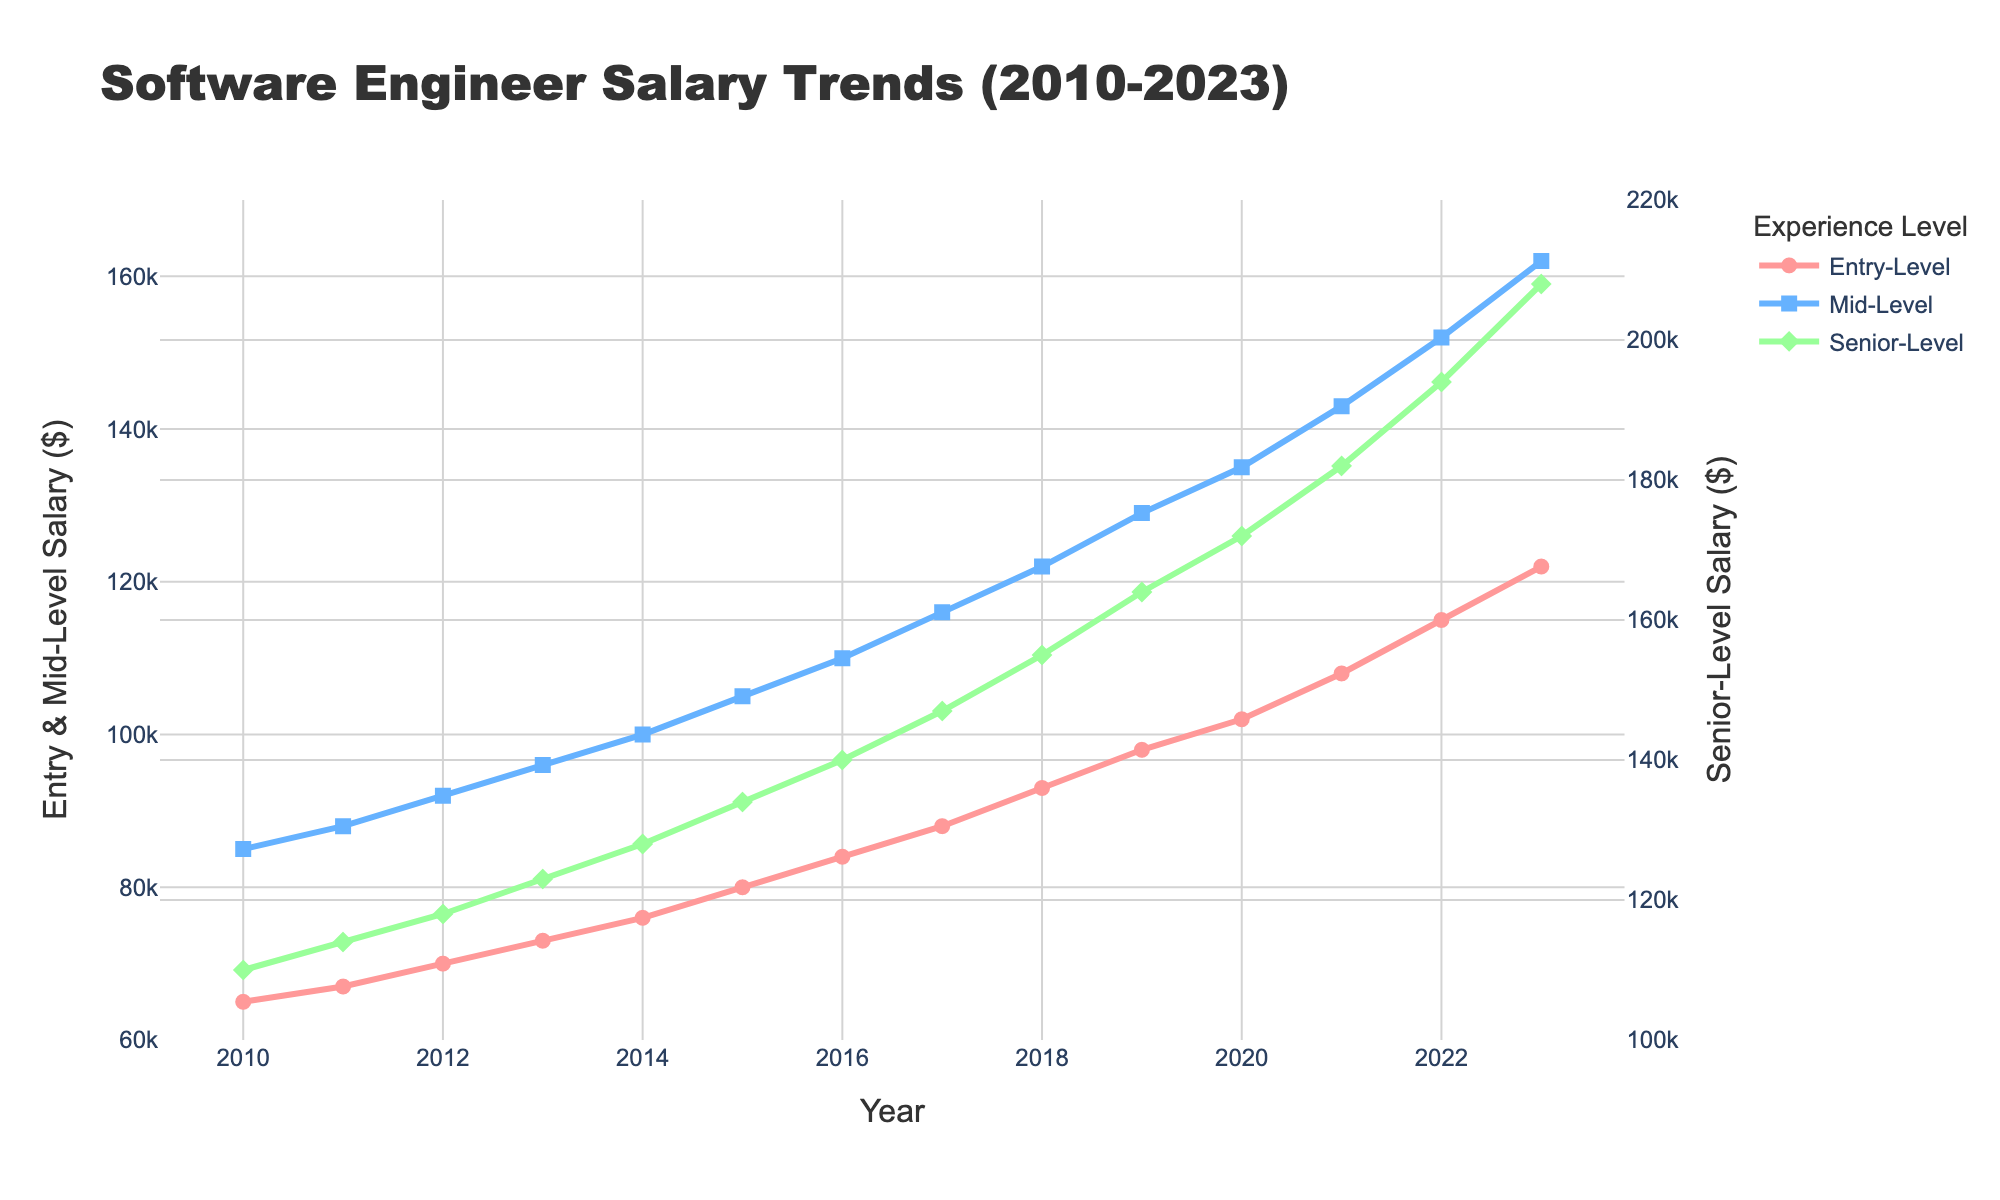What was the percentage increase in the senior-level salary from 2010 to 2023? The senior-level salary in 2010 was 110,000 and in 2023 it was 208,000. The percentage increase is calculated using the formula ((208,000 - 110,000) / 110,000) * 100 = 89.09%.
Answer: 89.09% Between which years did the mid-level salary experience the highest absolute increase? To find the highest absolute increase for mid-level salaries, check the year-over-year differences: 2013-2012 (40,000), 2014-2013 (40,000), 2015-2014 (50,000), 2016-2015 (50,000), 2017-2016 (60,000), 2018-2017 (80,000), 2019-2018 (70,000), 2020-2019 (60,000), 2021-2020 (80,000), 2022-2021 (90,000), 2023-2022 (100,000). The highest increase happened between 2022 and 2023.
Answer: 2022 and 2023 In 2015, by how much did the entry-level salary differ from the senior-level salary? The entry-level salary in 2015 was 80,000 and the senior-level salary was 134,000. The difference is 134,000 - 80,000 = 54,000.
Answer: 54,000 What's the average yearly salary increase for mid-level engineers from 2010 to 2023? Calculate the average yearly increase by taking the total increase from 2010 (85,000) to 2023 (162,000) and dividing it by the number of years (162,000 - 85,000) / (2023 - 2010) = 77,000 / 13 ≈ 5,923.08.
Answer: 5,923.08 Which salary level had the steepest increase in value over the entire period 2010-2023? By comparing the total increases: Entry-Level (122,000 - 65,000 = 57,000), Mid-Level (162,000 - 85,000 = 77,000), and Senior-Level (208,000 - 110,000 = 98,000), the senior-level salary had the greatest increase.
Answer: Senior-Level How did the salary trends for entry-level and mid-level positions compare over the analyzed period? Visually inspecting the figure, both entry-level and mid-level salaries show steady increasing trends. To be precise, from 2010 to 2023, the entry-level salary increased by 57,000 and the mid-level by 77,000, with mid-level salaries increasing at a marginally higher rate.
Answer: Both increased steadily, mid-level slightly higher Between 2016 and 2019, which level had the greatest cumulative salary increase? Calculate the cumulative increases: Entry-Level (98,000 - 84,000 = 14,000), Mid-Level (129,000 - 110,000 = 19,000), and Senior-Level (164,000 - 140,000 = 24,000). The senior-level had the greatest cumulative increase.
Answer: Senior-Level What's the visual difference in marker shapes used for entry-level and senior-level salaries? In the visual representation, entry-level salaries are marked with circles and senior-level salaries with diamonds.
Answer: Circles and Diamonds 